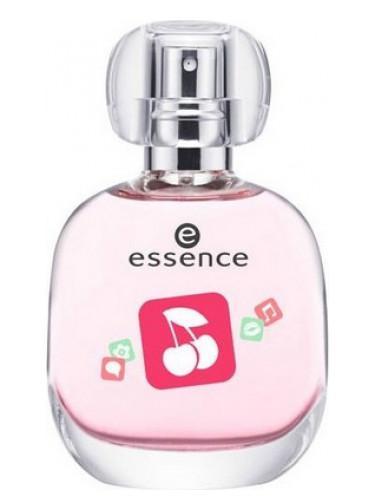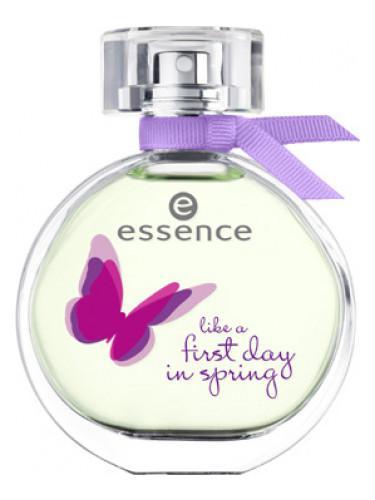The first image is the image on the left, the second image is the image on the right. For the images shown, is this caption "One bottle has a purple bow." true? Answer yes or no. Yes. 